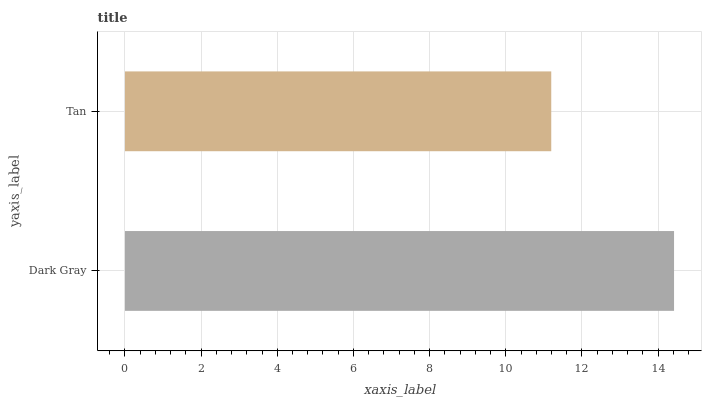Is Tan the minimum?
Answer yes or no. Yes. Is Dark Gray the maximum?
Answer yes or no. Yes. Is Tan the maximum?
Answer yes or no. No. Is Dark Gray greater than Tan?
Answer yes or no. Yes. Is Tan less than Dark Gray?
Answer yes or no. Yes. Is Tan greater than Dark Gray?
Answer yes or no. No. Is Dark Gray less than Tan?
Answer yes or no. No. Is Dark Gray the high median?
Answer yes or no. Yes. Is Tan the low median?
Answer yes or no. Yes. Is Tan the high median?
Answer yes or no. No. Is Dark Gray the low median?
Answer yes or no. No. 